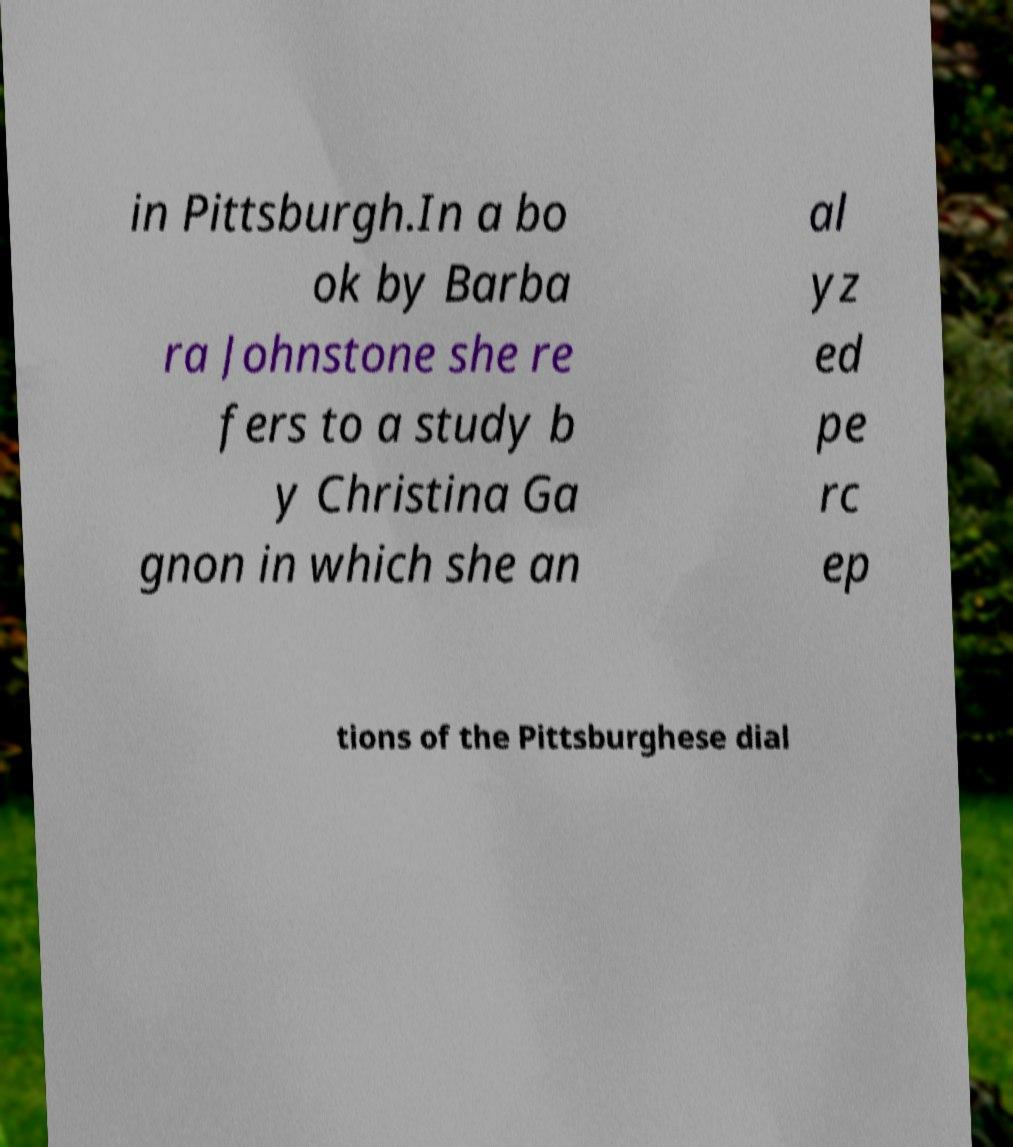Can you read and provide the text displayed in the image?This photo seems to have some interesting text. Can you extract and type it out for me? in Pittsburgh.In a bo ok by Barba ra Johnstone she re fers to a study b y Christina Ga gnon in which she an al yz ed pe rc ep tions of the Pittsburghese dial 